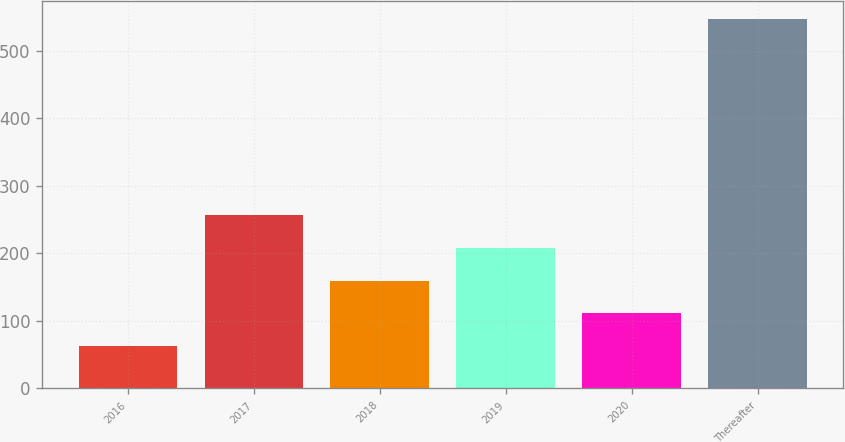Convert chart to OTSL. <chart><loc_0><loc_0><loc_500><loc_500><bar_chart><fcel>2016<fcel>2017<fcel>2018<fcel>2019<fcel>2020<fcel>Thereafter<nl><fcel>62.4<fcel>256.04<fcel>159.22<fcel>207.63<fcel>110.81<fcel>546.5<nl></chart> 